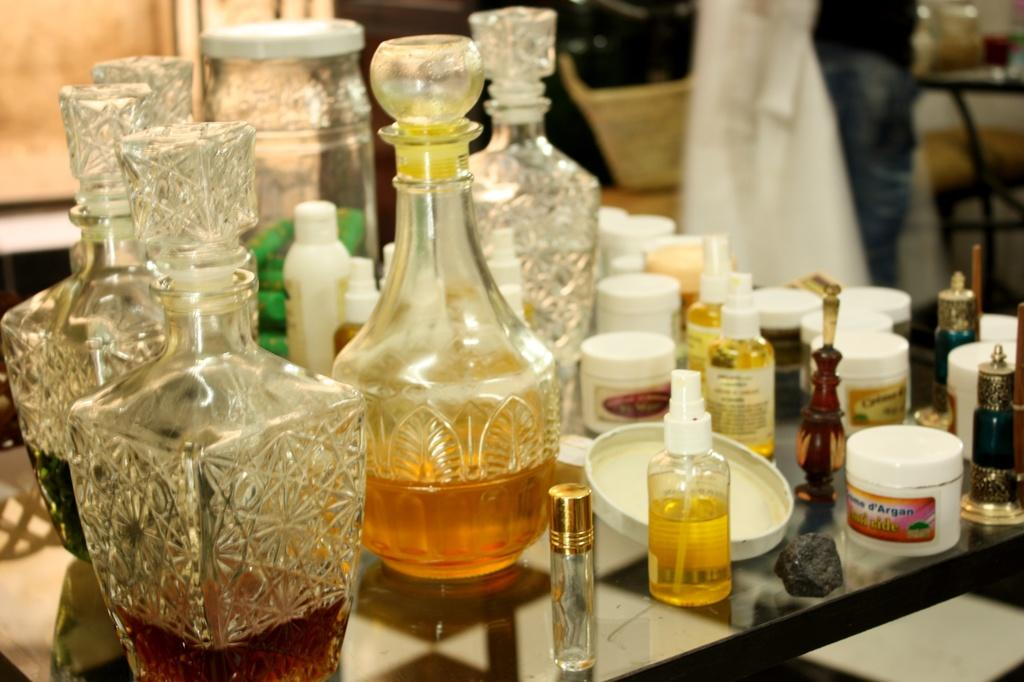<image>
Relay a brief, clear account of the picture shown. A table full of toiletries and decanters with a tub that says Argan on it. 